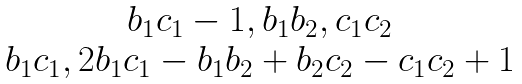Convert formula to latex. <formula><loc_0><loc_0><loc_500><loc_500>\begin{matrix} { b _ { 1 } c _ { 1 } - 1 , b _ { 1 } b _ { 2 } , c _ { 1 } c _ { 2 } } \\ { b _ { 1 } c _ { 1 } , 2 b _ { 1 } c _ { 1 } - b _ { 1 } b _ { 2 } + b _ { 2 } c _ { 2 } - c _ { 1 } c _ { 2 } + 1 } \end{matrix}</formula> 